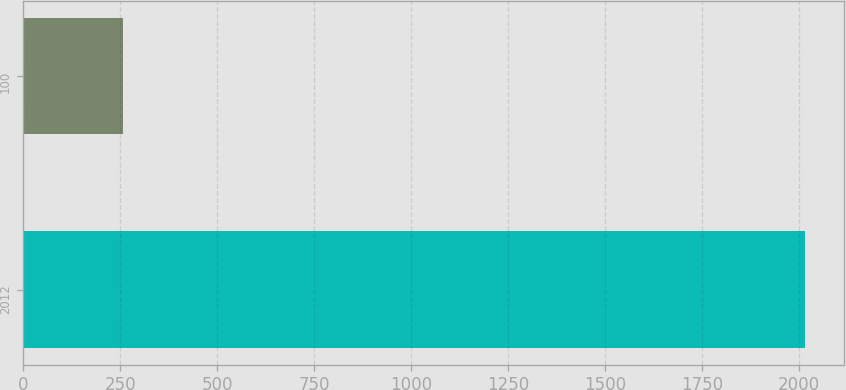Convert chart. <chart><loc_0><loc_0><loc_500><loc_500><bar_chart><fcel>2012<fcel>100<nl><fcel>2017<fcel>257<nl></chart> 